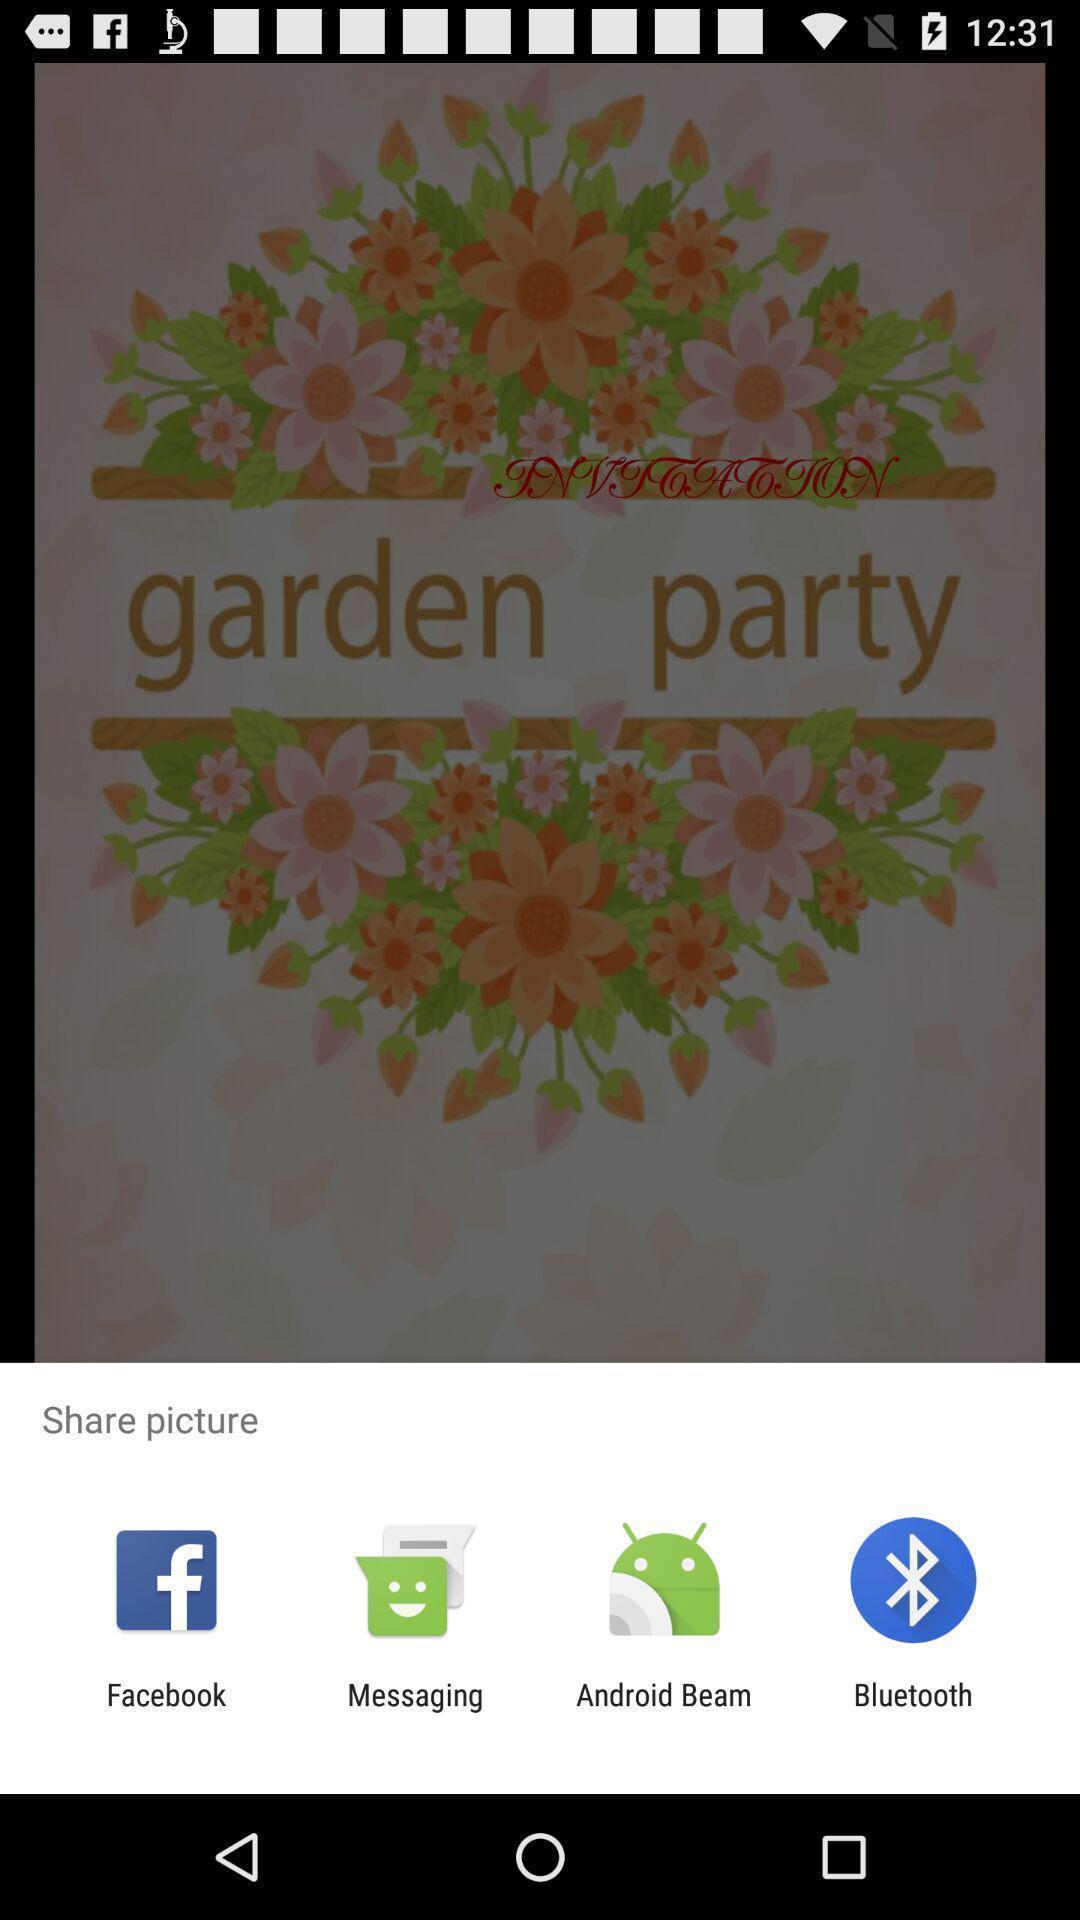Tell me what you see in this picture. Popup showing few options with icons in cards making app. 